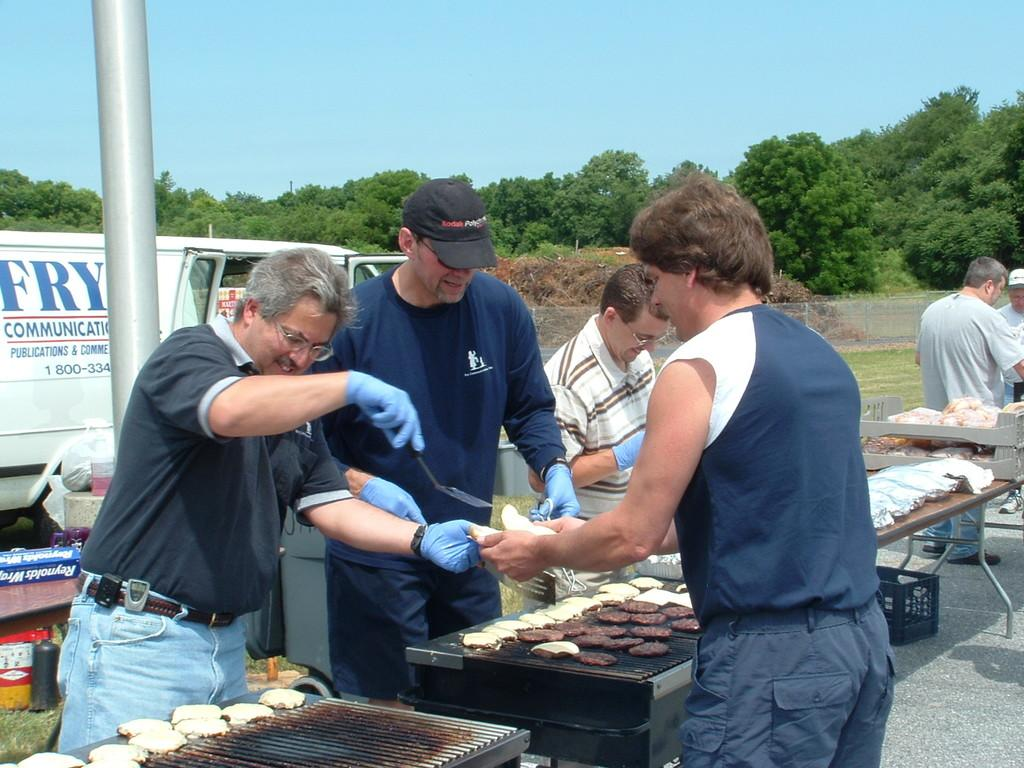<image>
Create a compact narrative representing the image presented. Some men work behind a grill and serve another man, a ban saying Fry Communications behind them. 